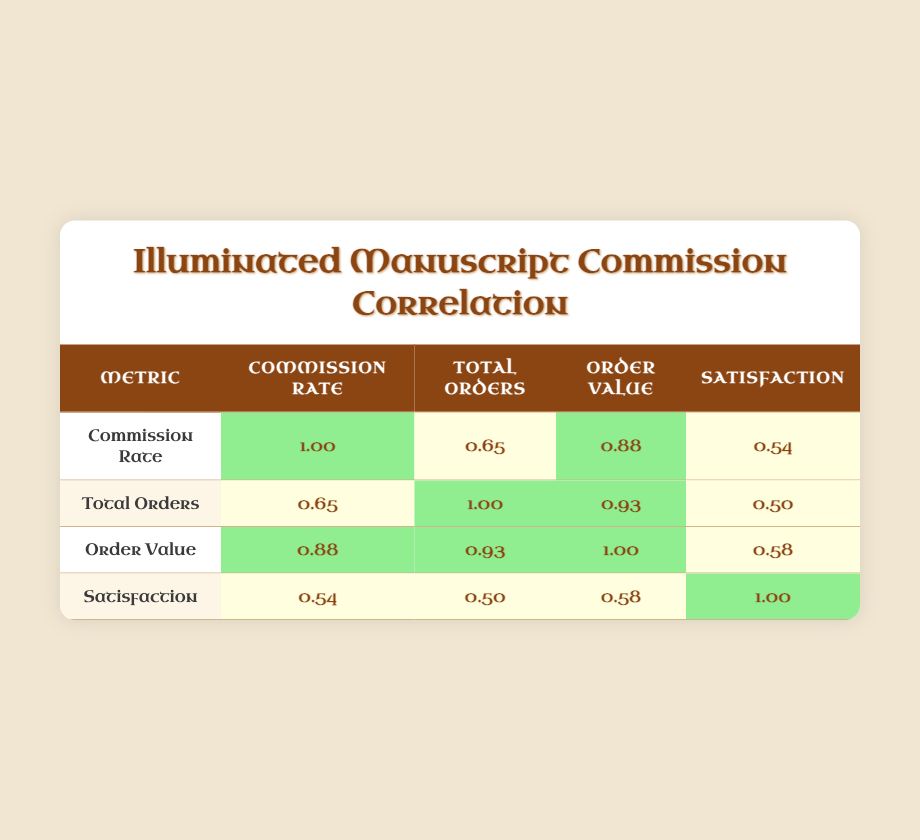What is the average commission rate for the year 2021? According to the table, the average commission rate for 2021 is found in the corresponding row, which states it is 14.0.
Answer: 14.0 What year had the highest client satisfaction score? To determine this, we look at all the client satisfaction scores listed for each year. The highest score of 5.0 appears for the year 2023.
Answer: 2023 How many total orders were there in 2020? The total orders for the year 2020 can be found in its row, which shows a total of 40 orders.
Answer: 40 What is the difference in average order value between 2019 and 2023? The average order value for 2019 is 300, and for 2023 it is 500. The difference can be calculated as 500 - 300 = 200.
Answer: 200 Is it true that the average commission rate increased every year from 2018 to 2023? We can see the average commission rates for each year: 12.5 (2018), 13.0 (2019), 15.0 (2020), 14.0 (2021), 14.5 (2022), and 16.0 (2023). The data shows that there was a decrease from 15.0 (2020) to 14.0 (2021), so the statement is false.
Answer: No What is the average of the total orders from 2018 to 2023? The total orders for each year are: 30 (2018), 45 (2019), 40 (2020), 50 (2021), 55 (2022), and 65 (2023). To find the average, we sum them up: 30 + 45 + 40 + 50 + 55 + 65 = 285. Then, we divide by the number of years (6): 285/6 = 47.5.
Answer: 47.5 How does the client satisfaction score correlate with the average commission rate? From the correlation values in the table, the correlation between the client satisfaction score and the average commission rate is 0.54, indicating a medium positive correlation, meaning higher commissions may slightly relate to higher satisfaction.
Answer: Medium positive correlation What was the highest average order value recorded, and in which year? The highest average order value can be found in the table, which shows 500 for the year 2023.
Answer: 500 in 2023 